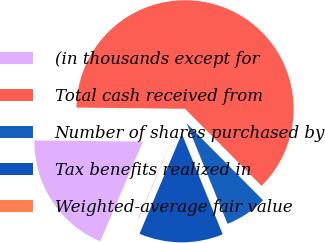Convert chart. <chart><loc_0><loc_0><loc_500><loc_500><pie_chart><fcel>(in thousands except for<fcel>Total cash received from<fcel>Number of shares purchased by<fcel>Tax benefits realized in<fcel>Weighted-average fair value<nl><fcel>18.75%<fcel>62.37%<fcel>6.29%<fcel>12.52%<fcel>0.06%<nl></chart> 